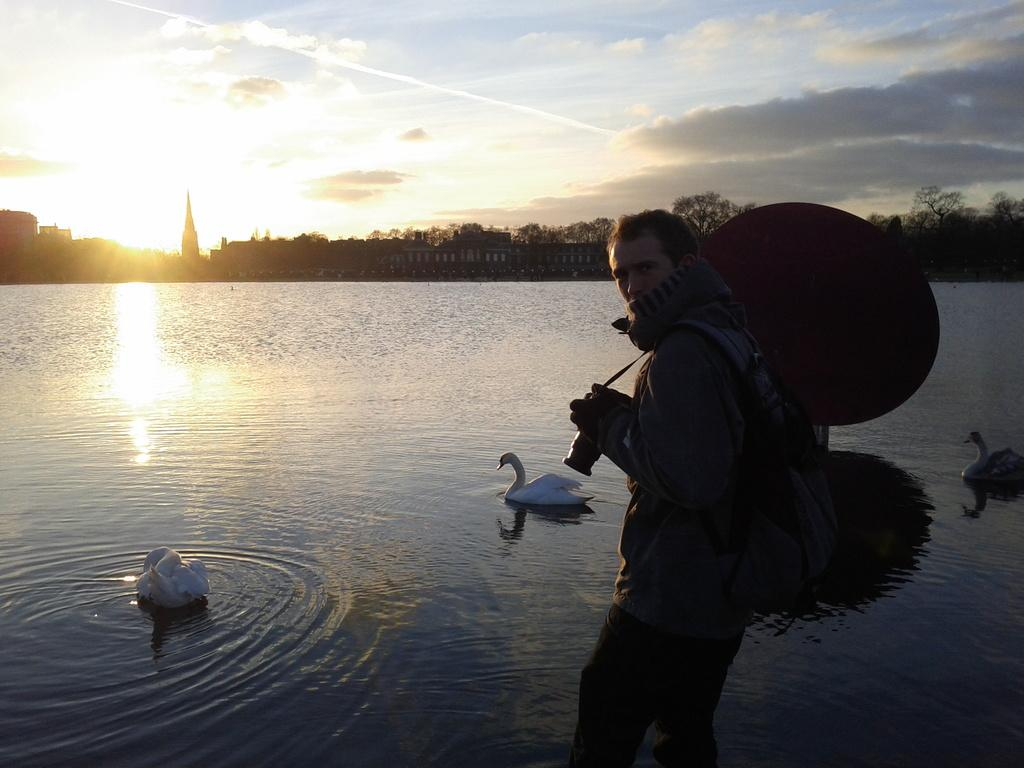Who is present on the right side of the image? There is a man on the right side of the image. What animals can be seen in the middle of the image? There are birds in the middle of the image, on the water. What type of vegetation is visible in the background of the image? There are trees in the background of the image. What type of structures can be seen in the background of the image? There are buildings in the background of the image. What is visible at the top of the image? The sky is visible at the top of the image. What type of quartz can be seen in the image? There is no quartz present in the image. Is the man in the image being held in jail? There is no indication of a jail or any imprisonment in the image. 